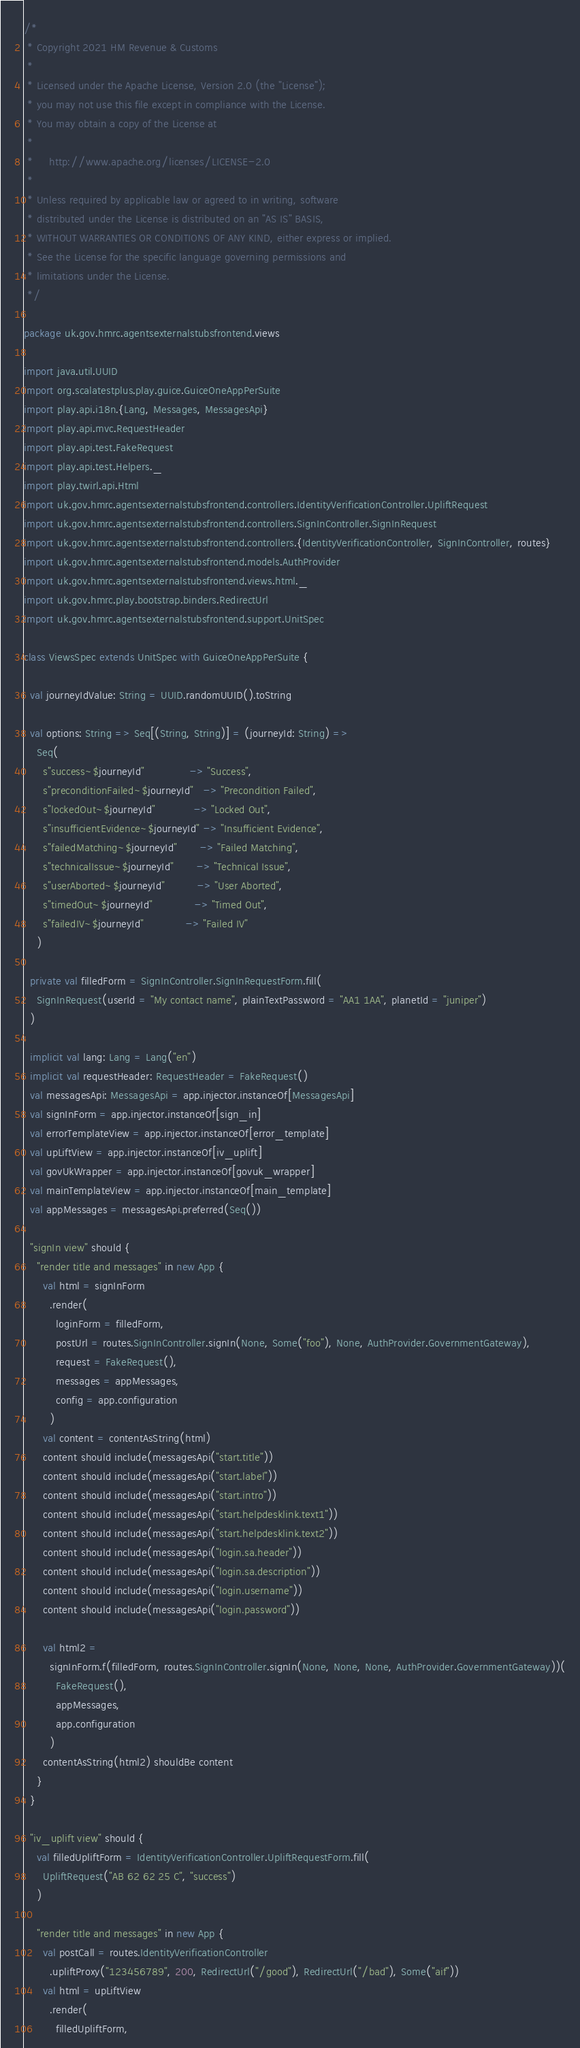<code> <loc_0><loc_0><loc_500><loc_500><_Scala_>/*
 * Copyright 2021 HM Revenue & Customs
 *
 * Licensed under the Apache License, Version 2.0 (the "License");
 * you may not use this file except in compliance with the License.
 * You may obtain a copy of the License at
 *
 *     http://www.apache.org/licenses/LICENSE-2.0
 *
 * Unless required by applicable law or agreed to in writing, software
 * distributed under the License is distributed on an "AS IS" BASIS,
 * WITHOUT WARRANTIES OR CONDITIONS OF ANY KIND, either express or implied.
 * See the License for the specific language governing permissions and
 * limitations under the License.
 */

package uk.gov.hmrc.agentsexternalstubsfrontend.views

import java.util.UUID
import org.scalatestplus.play.guice.GuiceOneAppPerSuite
import play.api.i18n.{Lang, Messages, MessagesApi}
import play.api.mvc.RequestHeader
import play.api.test.FakeRequest
import play.api.test.Helpers._
import play.twirl.api.Html
import uk.gov.hmrc.agentsexternalstubsfrontend.controllers.IdentityVerificationController.UpliftRequest
import uk.gov.hmrc.agentsexternalstubsfrontend.controllers.SignInController.SignInRequest
import uk.gov.hmrc.agentsexternalstubsfrontend.controllers.{IdentityVerificationController, SignInController, routes}
import uk.gov.hmrc.agentsexternalstubsfrontend.models.AuthProvider
import uk.gov.hmrc.agentsexternalstubsfrontend.views.html._
import uk.gov.hmrc.play.bootstrap.binders.RedirectUrl
import uk.gov.hmrc.agentsexternalstubsfrontend.support.UnitSpec

class ViewsSpec extends UnitSpec with GuiceOneAppPerSuite {

  val journeyIdValue: String = UUID.randomUUID().toString

  val options: String => Seq[(String, String)] = (journeyId: String) =>
    Seq(
      s"success~$journeyId"              -> "Success",
      s"preconditionFailed~$journeyId"   -> "Precondition Failed",
      s"lockedOut~$journeyId"            -> "Locked Out",
      s"insufficientEvidence~$journeyId" -> "Insufficient Evidence",
      s"failedMatching~$journeyId"       -> "Failed Matching",
      s"technicalIssue~$journeyId"       -> "Technical Issue",
      s"userAborted~$journeyId"          -> "User Aborted",
      s"timedOut~$journeyId"             -> "Timed Out",
      s"failedIV~$journeyId"             -> "Failed IV"
    )

  private val filledForm = SignInController.SignInRequestForm.fill(
    SignInRequest(userId = "My contact name", plainTextPassword = "AA1 1AA", planetId = "juniper")
  )

  implicit val lang: Lang = Lang("en")
  implicit val requestHeader: RequestHeader = FakeRequest()
  val messagesApi: MessagesApi = app.injector.instanceOf[MessagesApi]
  val signInForm = app.injector.instanceOf[sign_in]
  val errorTemplateView = app.injector.instanceOf[error_template]
  val upLiftView = app.injector.instanceOf[iv_uplift]
  val govUkWrapper = app.injector.instanceOf[govuk_wrapper]
  val mainTemplateView = app.injector.instanceOf[main_template]
  val appMessages = messagesApi.preferred(Seq())

  "signIn view" should {
    "render title and messages" in new App {
      val html = signInForm
        .render(
          loginForm = filledForm,
          postUrl = routes.SignInController.signIn(None, Some("foo"), None, AuthProvider.GovernmentGateway),
          request = FakeRequest(),
          messages = appMessages,
          config = app.configuration
        )
      val content = contentAsString(html)
      content should include(messagesApi("start.title"))
      content should include(messagesApi("start.label"))
      content should include(messagesApi("start.intro"))
      content should include(messagesApi("start.helpdesklink.text1"))
      content should include(messagesApi("start.helpdesklink.text2"))
      content should include(messagesApi("login.sa.header"))
      content should include(messagesApi("login.sa.description"))
      content should include(messagesApi("login.username"))
      content should include(messagesApi("login.password"))

      val html2 =
        signInForm.f(filledForm, routes.SignInController.signIn(None, None, None, AuthProvider.GovernmentGateway))(
          FakeRequest(),
          appMessages,
          app.configuration
        )
      contentAsString(html2) shouldBe content
    }
  }

  "iv_uplift view" should {
    val filledUpliftForm = IdentityVerificationController.UpliftRequestForm.fill(
      UpliftRequest("AB 62 62 25 C", "success")
    )

    "render title and messages" in new App {
      val postCall = routes.IdentityVerificationController
        .upliftProxy("123456789", 200, RedirectUrl("/good"), RedirectUrl("/bad"), Some("aif"))
      val html = upLiftView
        .render(
          filledUpliftForm,</code> 